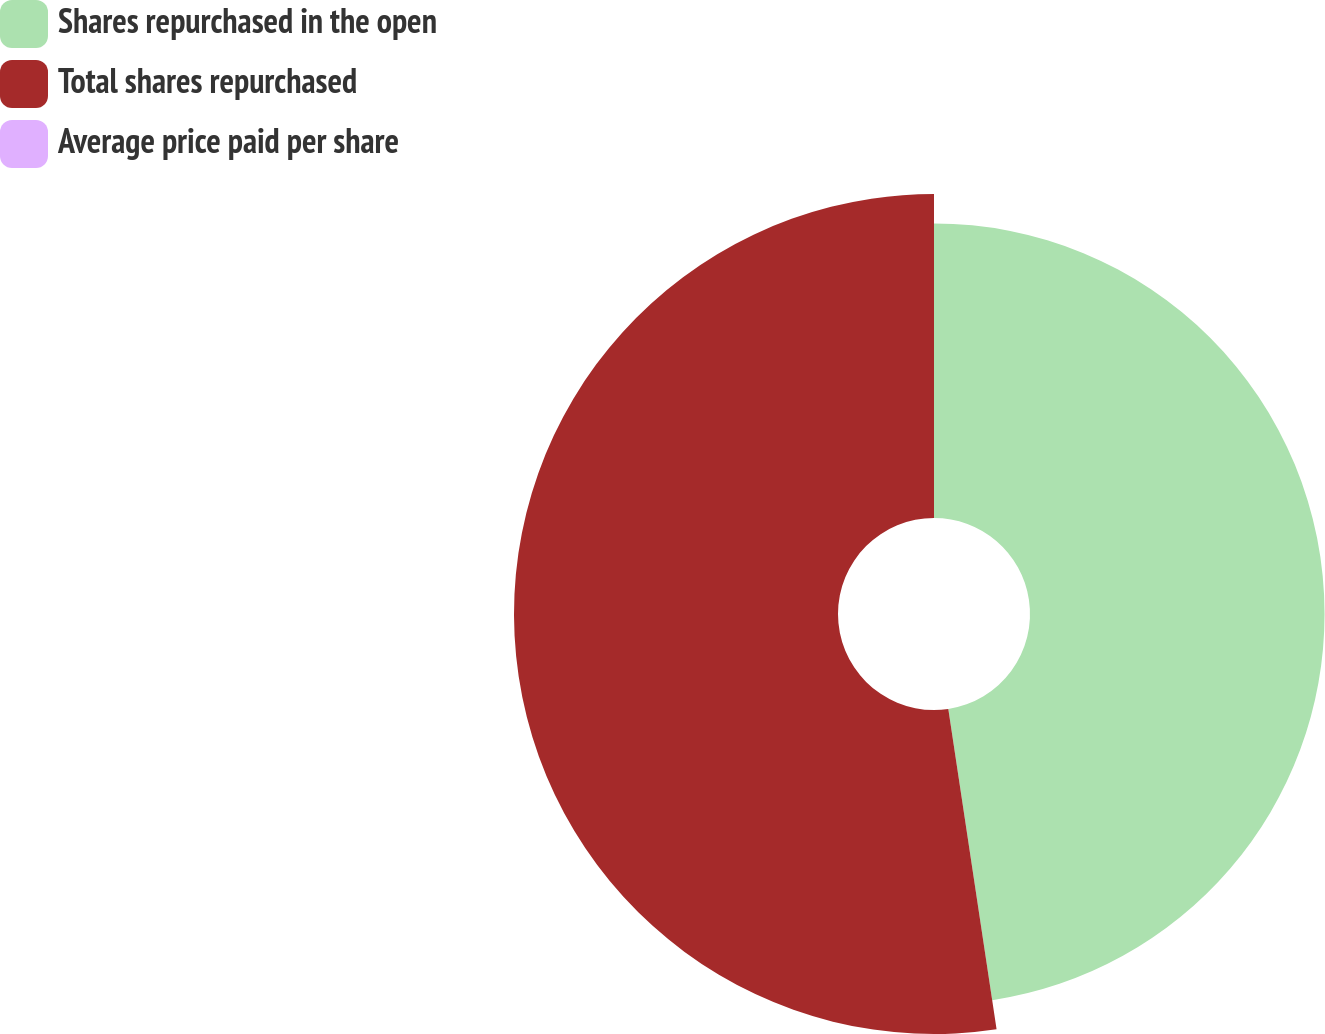Convert chart. <chart><loc_0><loc_0><loc_500><loc_500><pie_chart><fcel>Shares repurchased in the open<fcel>Total shares repurchased<fcel>Average price paid per share<nl><fcel>47.62%<fcel>52.38%<fcel>0.0%<nl></chart> 